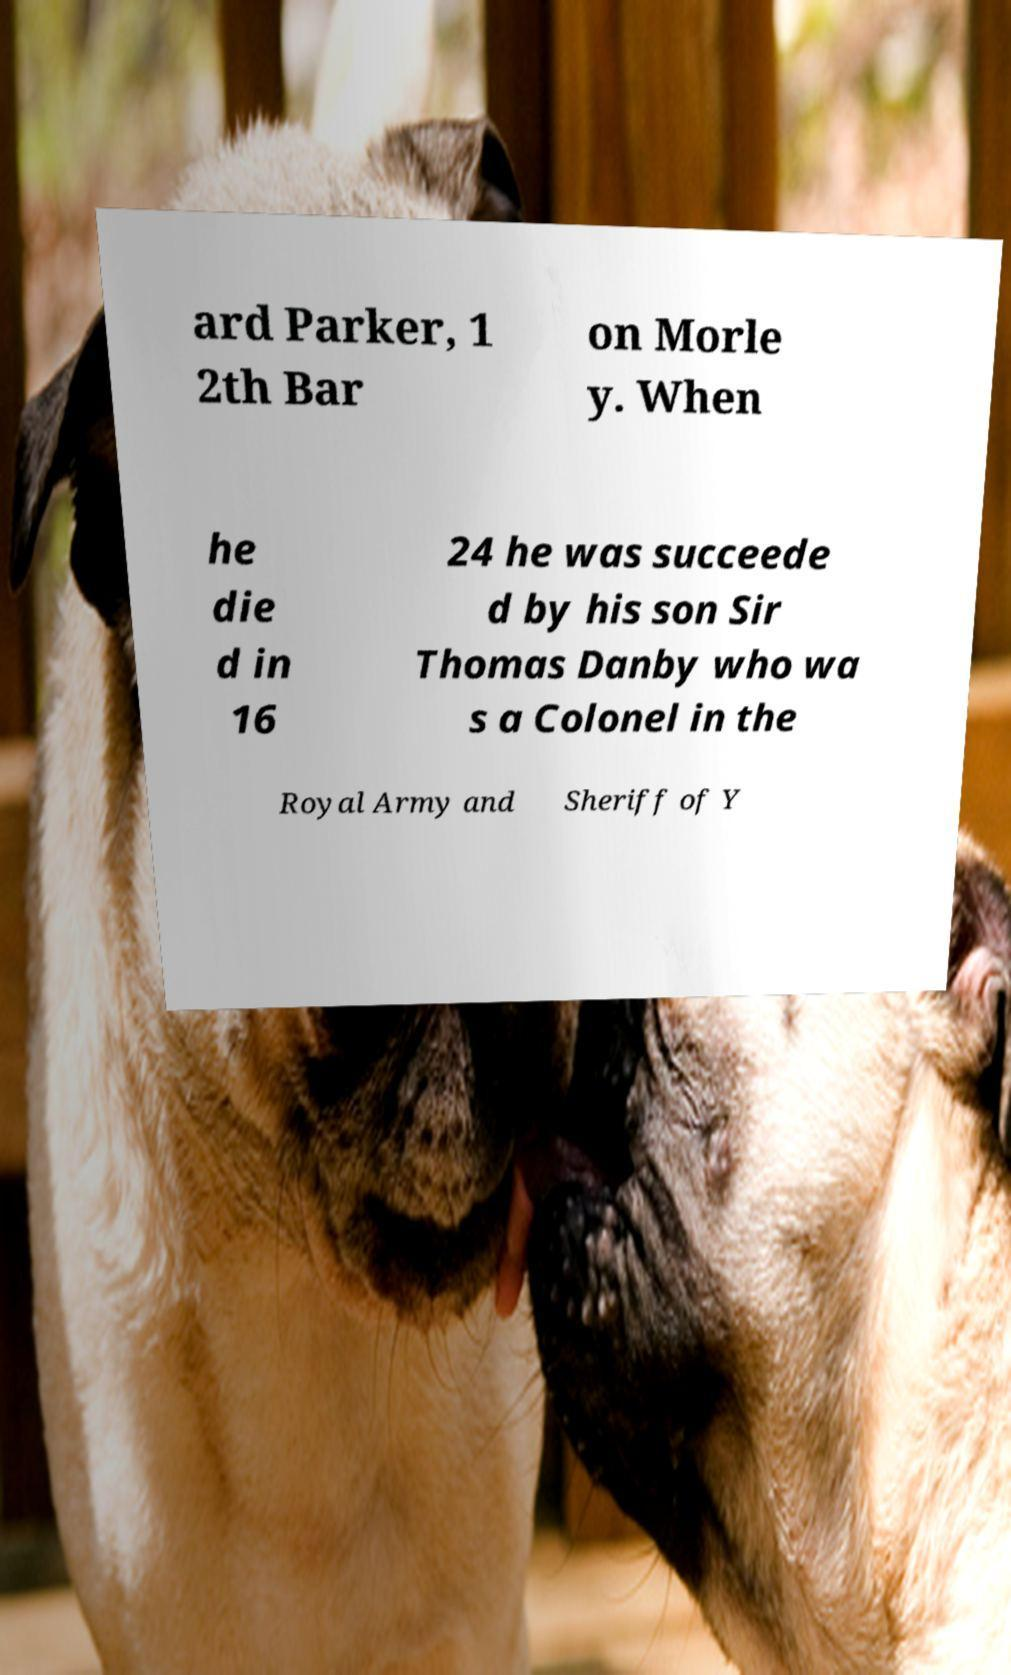What messages or text are displayed in this image? I need them in a readable, typed format. ard Parker, 1 2th Bar on Morle y. When he die d in 16 24 he was succeede d by his son Sir Thomas Danby who wa s a Colonel in the Royal Army and Sheriff of Y 